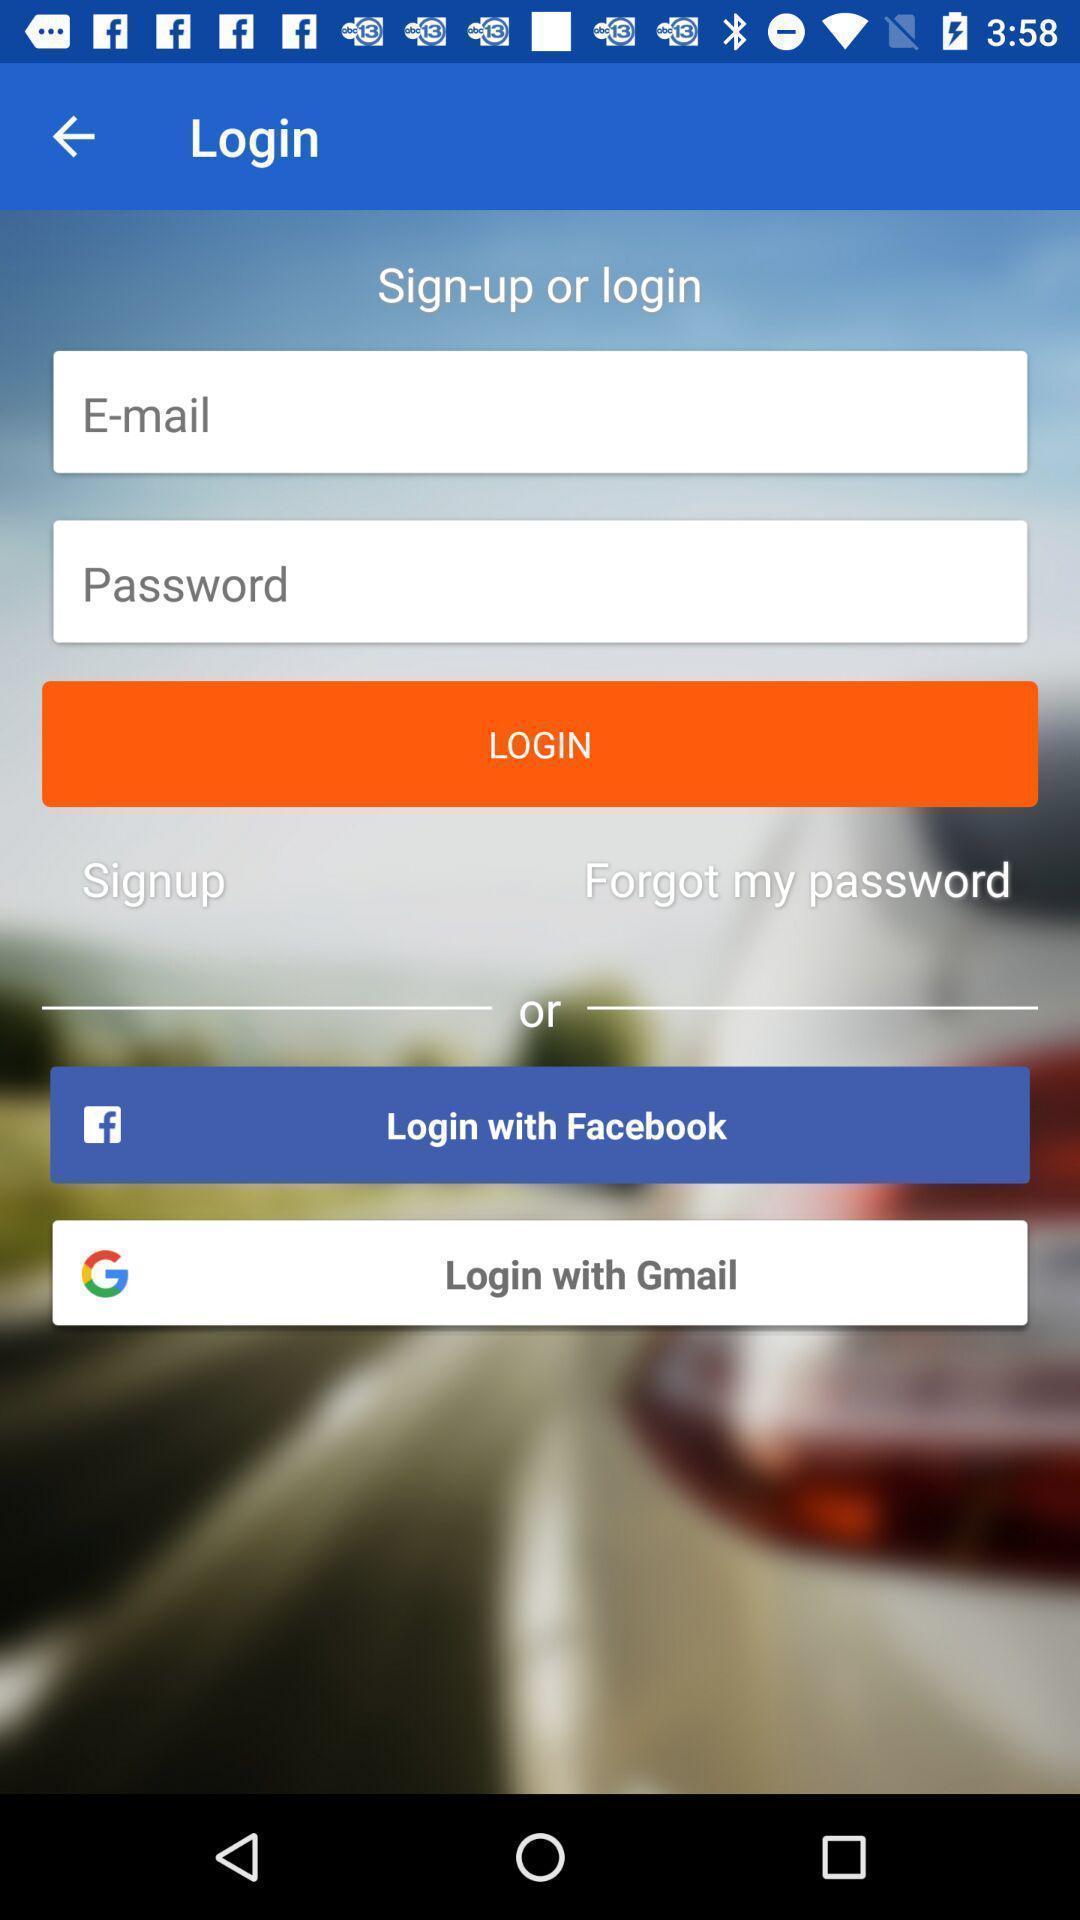Provide a description of this screenshot. Sign up/log in page. 